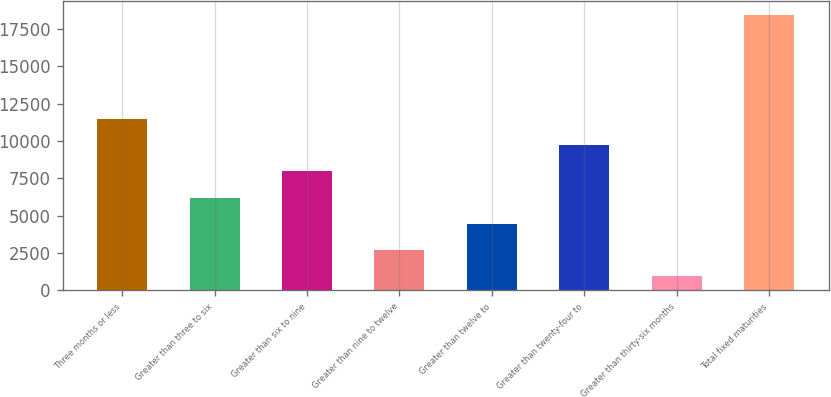Convert chart to OTSL. <chart><loc_0><loc_0><loc_500><loc_500><bar_chart><fcel>Three months or less<fcel>Greater than three to six<fcel>Greater than six to nine<fcel>Greater than nine to twelve<fcel>Greater than twelve to<fcel>Greater than twenty-four to<fcel>Greater than thirty-six months<fcel>Total fixed maturities<nl><fcel>11458.8<fcel>6215.47<fcel>7963.26<fcel>2719.89<fcel>4467.68<fcel>9711.05<fcel>972.1<fcel>18450<nl></chart> 